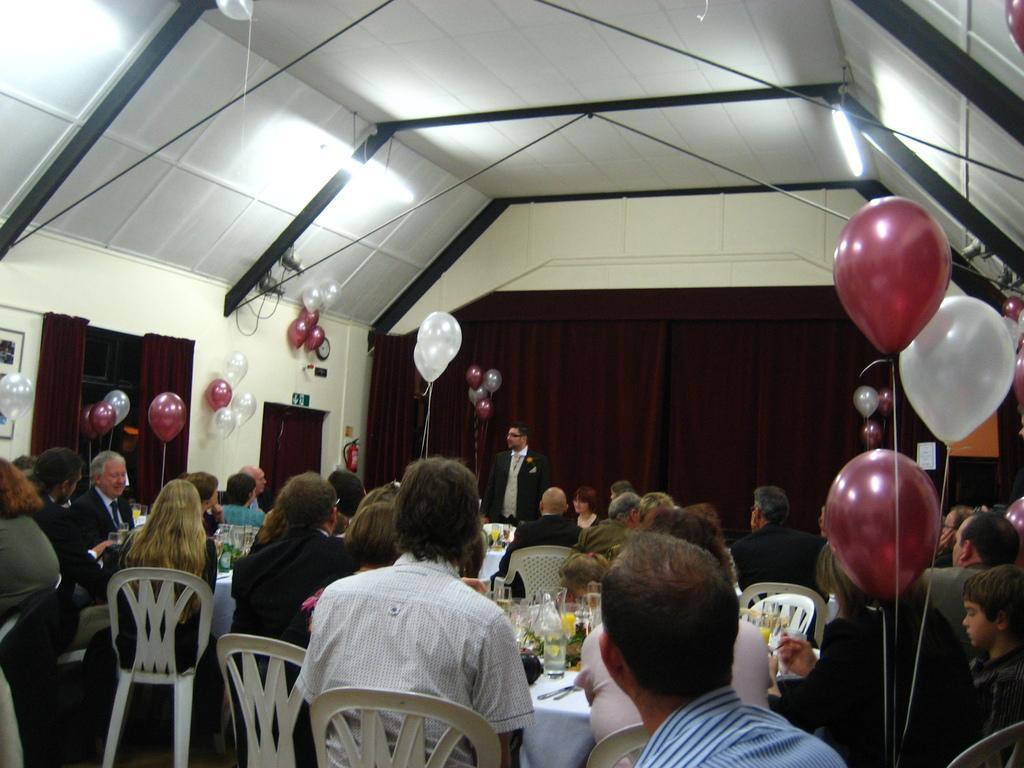In one or two sentences, can you explain what this image depicts? here we can see a group of people sitting on a chair, and infront here is the table and some objects on it, and here a person is standing and here are the balloons ,and at the top here is the roof ,and here is the lights, and here is the wall. 